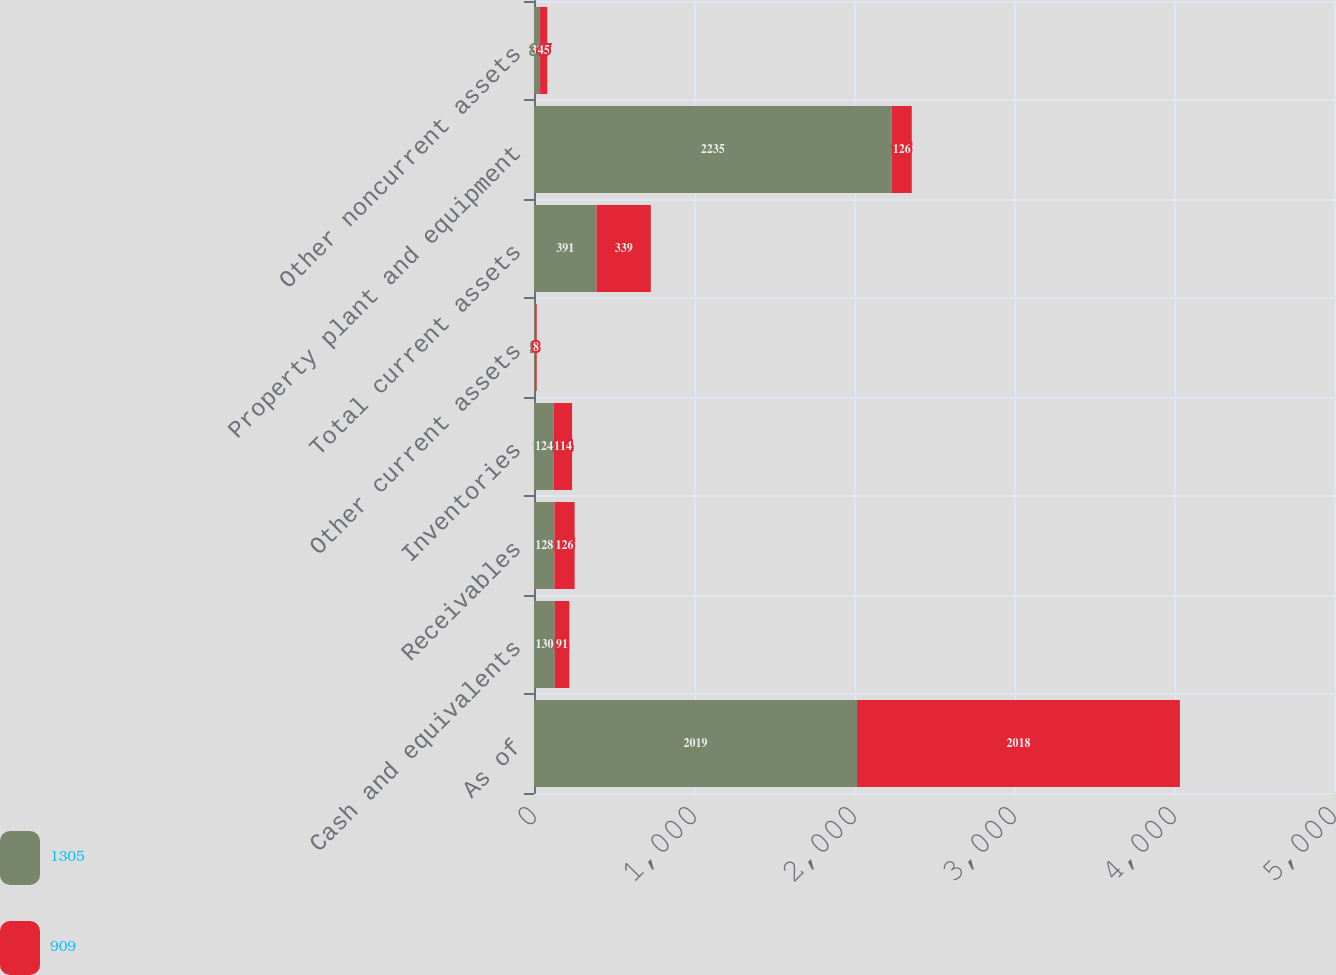Convert chart. <chart><loc_0><loc_0><loc_500><loc_500><stacked_bar_chart><ecel><fcel>As of<fcel>Cash and equivalents<fcel>Receivables<fcel>Inventories<fcel>Other current assets<fcel>Total current assets<fcel>Property plant and equipment<fcel>Other noncurrent assets<nl><fcel>1305<fcel>2019<fcel>130<fcel>128<fcel>124<fcel>9<fcel>391<fcel>2235<fcel>38<nl><fcel>909<fcel>2018<fcel>91<fcel>126<fcel>114<fcel>8<fcel>339<fcel>126<fcel>45<nl></chart> 